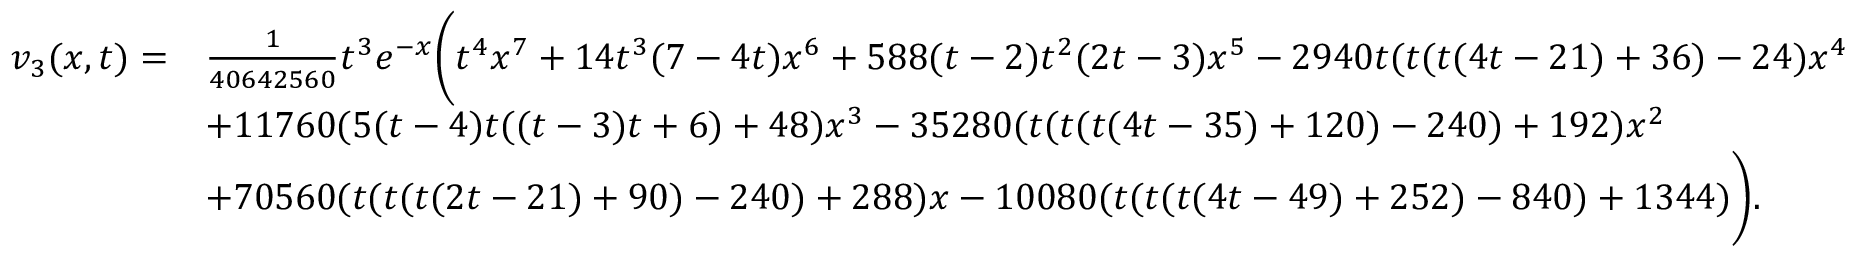Convert formula to latex. <formula><loc_0><loc_0><loc_500><loc_500>\begin{array} { r l } { v _ { 3 } ( x , t ) = } & { \frac { 1 } { 4 0 6 4 2 5 6 0 } t ^ { 3 } e ^ { - x } \left ( t ^ { 4 } x ^ { 7 } + 1 4 t ^ { 3 } ( 7 - 4 t ) x ^ { 6 } + 5 8 8 ( t - 2 ) t ^ { 2 } ( 2 t - 3 ) x ^ { 5 } - 2 9 4 0 t ( t ( t ( 4 t - 2 1 ) + 3 6 ) - 2 4 ) x ^ { 4 } } \\ & { + 1 1 7 6 0 ( 5 ( t - 4 ) t ( ( t - 3 ) t + 6 ) + 4 8 ) x ^ { 3 } - 3 5 2 8 0 ( t ( t ( t ( 4 t - 3 5 ) + 1 2 0 ) - 2 4 0 ) + 1 9 2 ) x ^ { 2 } } \\ & { + 7 0 5 6 0 ( t ( t ( t ( 2 t - 2 1 ) + 9 0 ) - 2 4 0 ) + 2 8 8 ) x - 1 0 0 8 0 ( t ( t ( t ( 4 t - 4 9 ) + 2 5 2 ) - 8 4 0 ) + 1 3 4 4 ) \right ) . } \end{array}</formula> 